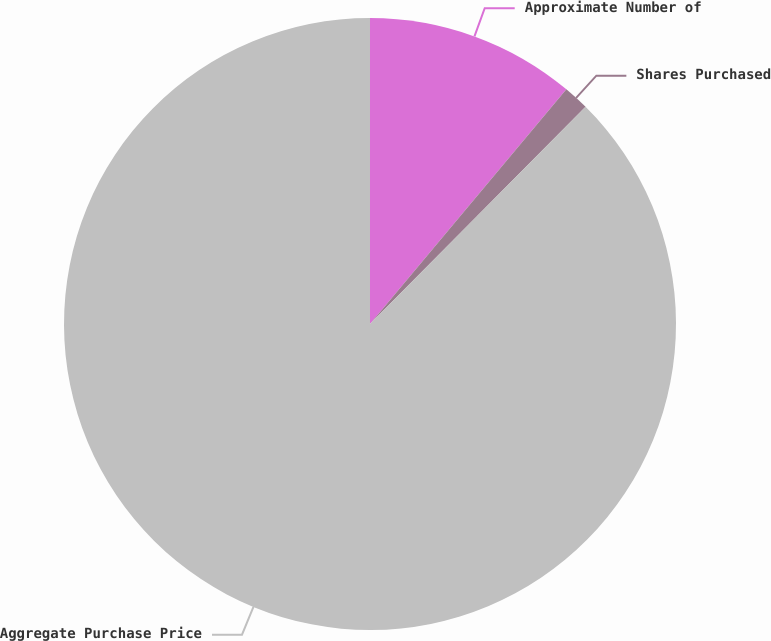Convert chart. <chart><loc_0><loc_0><loc_500><loc_500><pie_chart><fcel>Approximate Number of<fcel>Shares Purchased<fcel>Aggregate Purchase Price<nl><fcel>11.09%<fcel>1.35%<fcel>87.56%<nl></chart> 